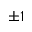<formula> <loc_0><loc_0><loc_500><loc_500>\pm 1</formula> 